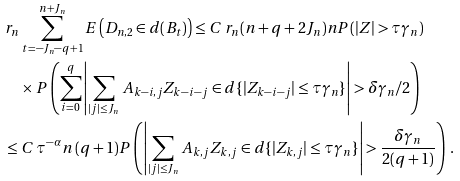<formula> <loc_0><loc_0><loc_500><loc_500>& r _ { n } \sum _ { t = - J _ { n } - q + 1 } ^ { n + J _ { n } } E \left ( D _ { n , 2 } \in d ( B _ { t } ) \right ) \leq C \, r _ { n } ( n + q + 2 J _ { n } ) n P ( | Z | > \tau \gamma _ { n } ) \\ & \quad \times P \left ( \sum _ { i = 0 } ^ { q } \left | \sum _ { | j | \leq J _ { n } } \, A _ { k - i , j } Z _ { k - i - j } \in d \{ | Z _ { k - i - j } | \leq \tau \gamma _ { n } \} \right | > \delta \gamma _ { n } / 2 \right ) \\ & \leq C \, \tau ^ { - \alpha } n \, ( q + 1 ) P \left ( \left | \sum _ { | j | \leq J _ { n } } \, A _ { k , j } Z _ { k , j } \in d \{ | Z _ { k , j } | \leq \tau \gamma _ { n } \} \right | > \frac { \delta \gamma _ { n } } { 2 ( q + 1 ) } \right ) \, .</formula> 